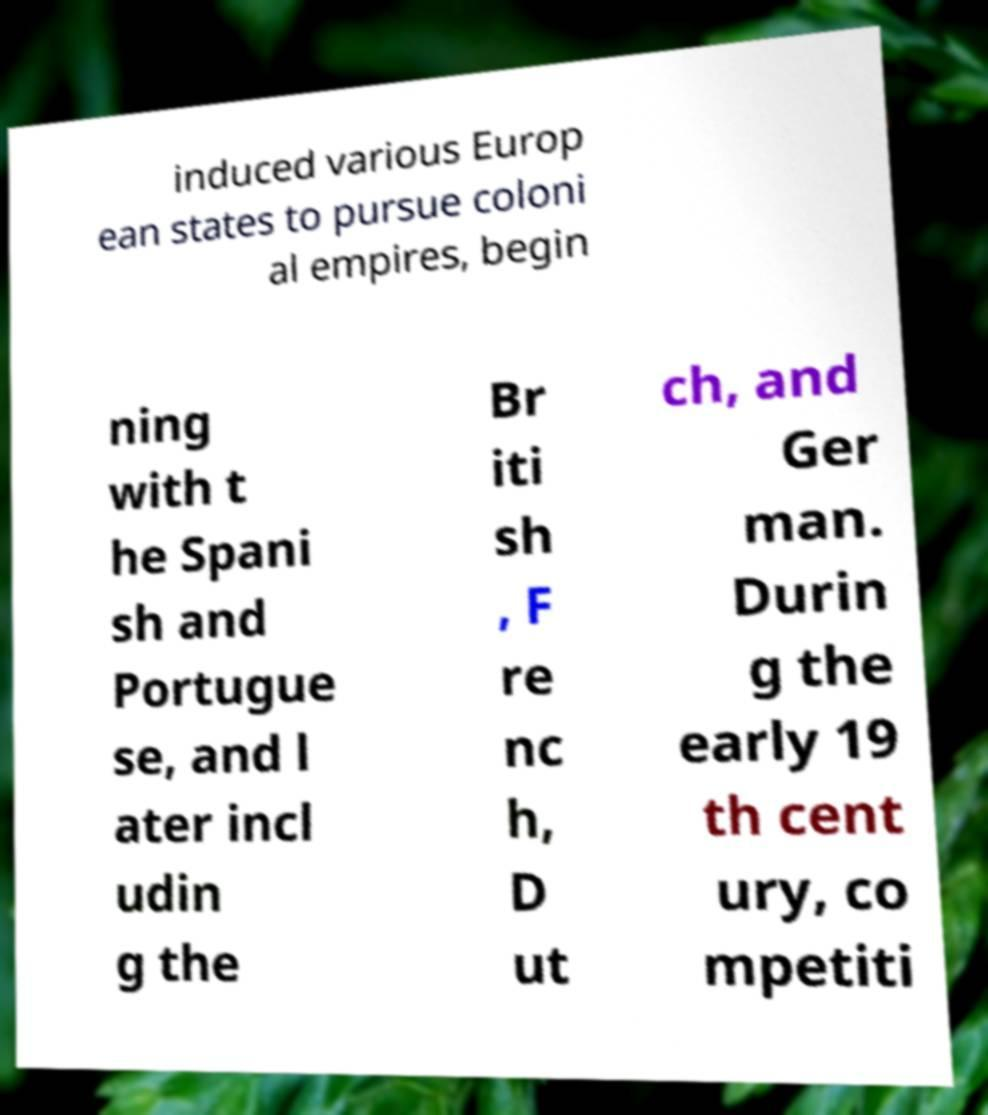What messages or text are displayed in this image? I need them in a readable, typed format. induced various Europ ean states to pursue coloni al empires, begin ning with t he Spani sh and Portugue se, and l ater incl udin g the Br iti sh , F re nc h, D ut ch, and Ger man. Durin g the early 19 th cent ury, co mpetiti 